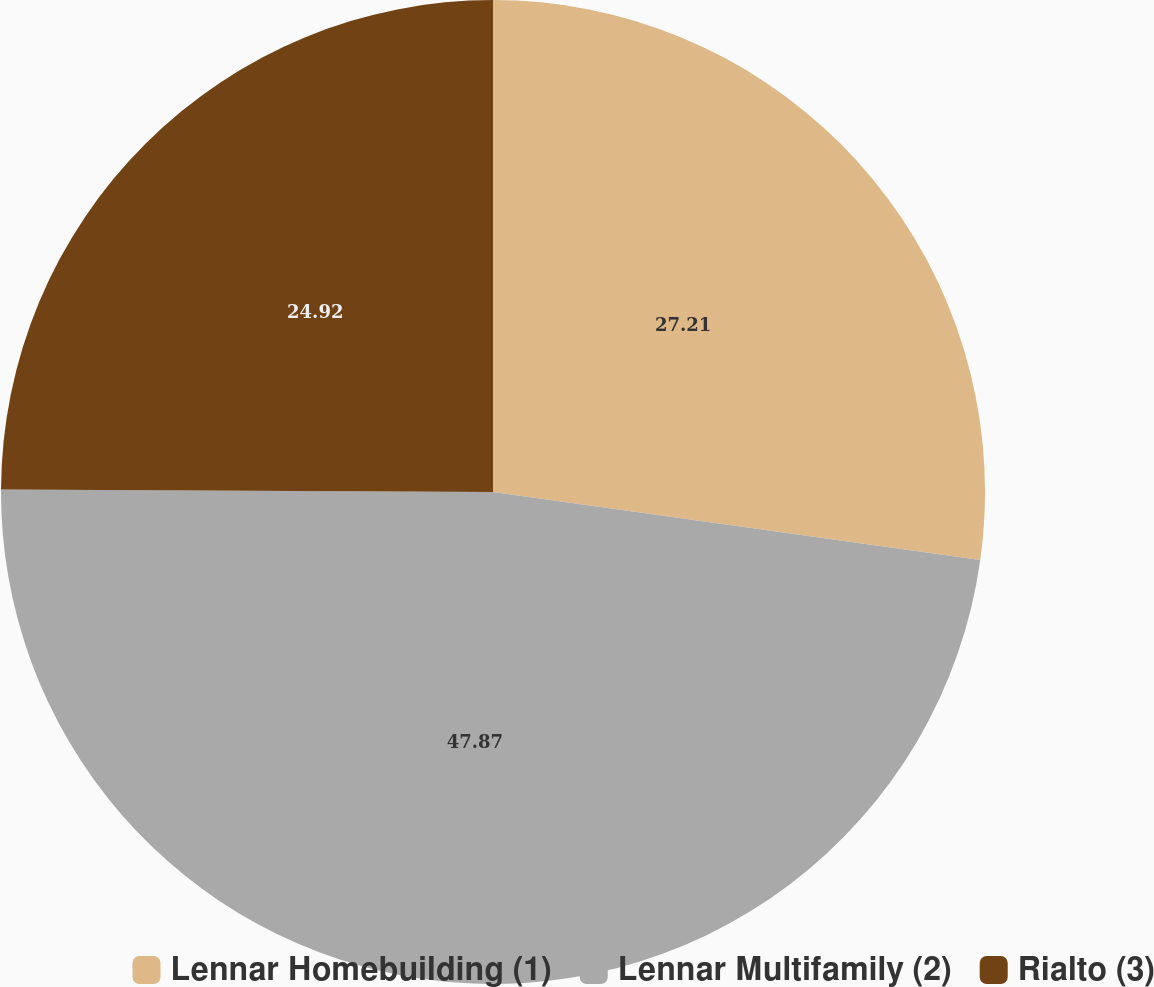<chart> <loc_0><loc_0><loc_500><loc_500><pie_chart><fcel>Lennar Homebuilding (1)<fcel>Lennar Multifamily (2)<fcel>Rialto (3)<nl><fcel>27.21%<fcel>47.87%<fcel>24.92%<nl></chart> 